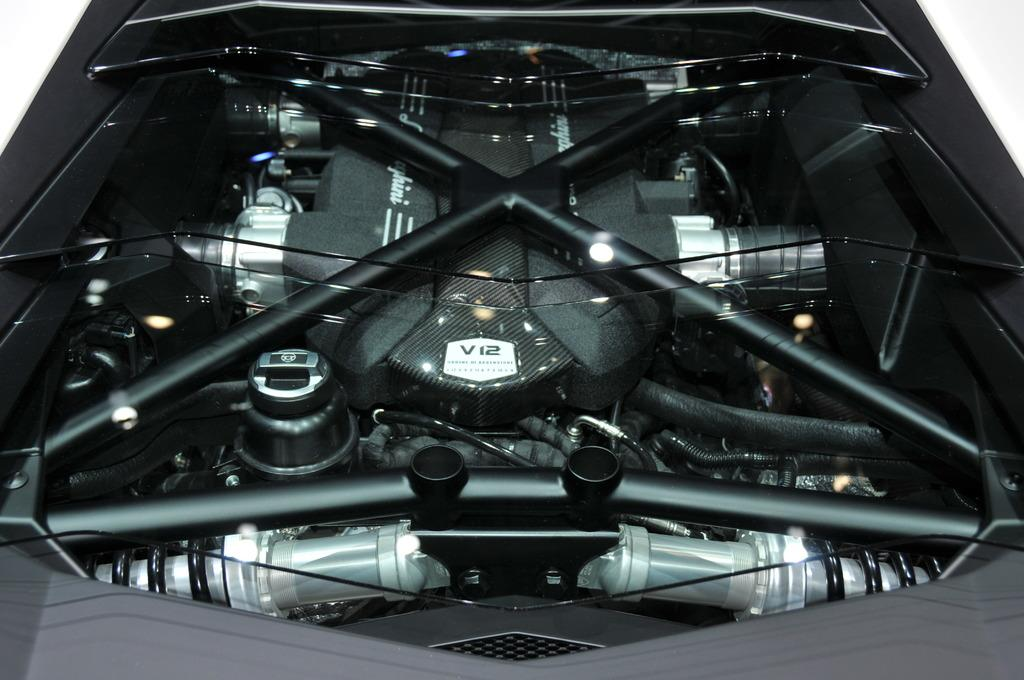What is the main subject of the image? The main subject of the image is a vehicle's engine. Can you describe the background of the image? The background of the image is white. What flavor of ice cream does the engine prefer? The engine does not have a flavor preference, as it is an inanimate object and cannot consume ice cream. 